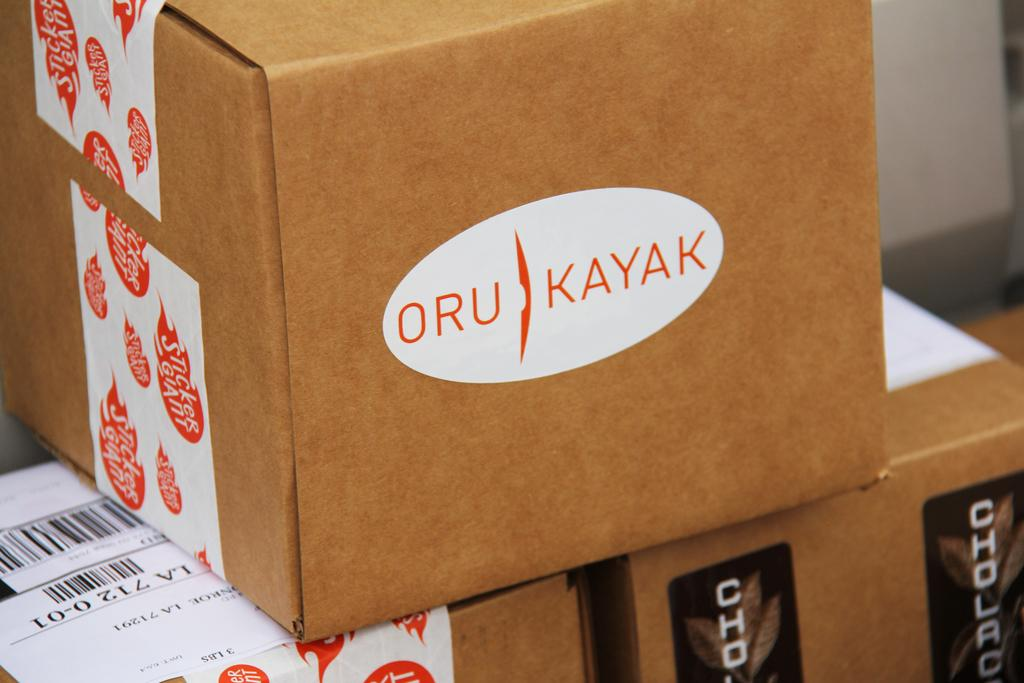<image>
Provide a brief description of the given image. a box with a label on the side of it that says 'oru kayak' 